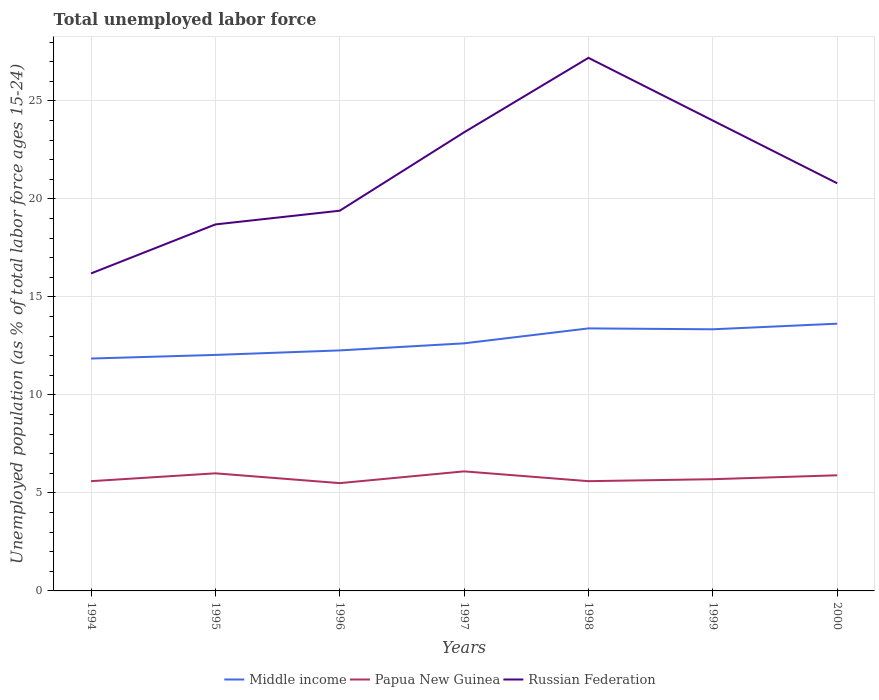Across all years, what is the maximum percentage of unemployed population in in Middle income?
Provide a succinct answer. 11.86. In which year was the percentage of unemployed population in in Russian Federation maximum?
Ensure brevity in your answer.  1994. What is the total percentage of unemployed population in in Middle income in the graph?
Keep it short and to the point. -1.31. What is the difference between the highest and the second highest percentage of unemployed population in in Papua New Guinea?
Your response must be concise. 0.6. What is the difference between the highest and the lowest percentage of unemployed population in in Middle income?
Provide a succinct answer. 3. How many years are there in the graph?
Keep it short and to the point. 7. What is the difference between two consecutive major ticks on the Y-axis?
Your answer should be very brief. 5. Are the values on the major ticks of Y-axis written in scientific E-notation?
Give a very brief answer. No. Does the graph contain grids?
Your answer should be very brief. Yes. Where does the legend appear in the graph?
Your answer should be very brief. Bottom center. How many legend labels are there?
Provide a succinct answer. 3. What is the title of the graph?
Ensure brevity in your answer.  Total unemployed labor force. What is the label or title of the Y-axis?
Your response must be concise. Unemployed population (as % of total labor force ages 15-24). What is the Unemployed population (as % of total labor force ages 15-24) of Middle income in 1994?
Make the answer very short. 11.86. What is the Unemployed population (as % of total labor force ages 15-24) of Papua New Guinea in 1994?
Provide a short and direct response. 5.6. What is the Unemployed population (as % of total labor force ages 15-24) in Russian Federation in 1994?
Provide a succinct answer. 16.2. What is the Unemployed population (as % of total labor force ages 15-24) of Middle income in 1995?
Provide a succinct answer. 12.04. What is the Unemployed population (as % of total labor force ages 15-24) in Russian Federation in 1995?
Your response must be concise. 18.7. What is the Unemployed population (as % of total labor force ages 15-24) in Middle income in 1996?
Ensure brevity in your answer.  12.27. What is the Unemployed population (as % of total labor force ages 15-24) of Papua New Guinea in 1996?
Make the answer very short. 5.5. What is the Unemployed population (as % of total labor force ages 15-24) of Russian Federation in 1996?
Make the answer very short. 19.4. What is the Unemployed population (as % of total labor force ages 15-24) in Middle income in 1997?
Give a very brief answer. 12.63. What is the Unemployed population (as % of total labor force ages 15-24) in Papua New Guinea in 1997?
Your answer should be very brief. 6.1. What is the Unemployed population (as % of total labor force ages 15-24) of Russian Federation in 1997?
Offer a very short reply. 23.4. What is the Unemployed population (as % of total labor force ages 15-24) of Middle income in 1998?
Make the answer very short. 13.4. What is the Unemployed population (as % of total labor force ages 15-24) in Papua New Guinea in 1998?
Provide a succinct answer. 5.6. What is the Unemployed population (as % of total labor force ages 15-24) of Russian Federation in 1998?
Provide a short and direct response. 27.2. What is the Unemployed population (as % of total labor force ages 15-24) of Middle income in 1999?
Give a very brief answer. 13.35. What is the Unemployed population (as % of total labor force ages 15-24) of Papua New Guinea in 1999?
Make the answer very short. 5.7. What is the Unemployed population (as % of total labor force ages 15-24) of Middle income in 2000?
Offer a terse response. 13.64. What is the Unemployed population (as % of total labor force ages 15-24) of Papua New Guinea in 2000?
Offer a very short reply. 5.9. What is the Unemployed population (as % of total labor force ages 15-24) of Russian Federation in 2000?
Your response must be concise. 20.8. Across all years, what is the maximum Unemployed population (as % of total labor force ages 15-24) in Middle income?
Ensure brevity in your answer.  13.64. Across all years, what is the maximum Unemployed population (as % of total labor force ages 15-24) in Papua New Guinea?
Keep it short and to the point. 6.1. Across all years, what is the maximum Unemployed population (as % of total labor force ages 15-24) in Russian Federation?
Offer a very short reply. 27.2. Across all years, what is the minimum Unemployed population (as % of total labor force ages 15-24) of Middle income?
Your answer should be compact. 11.86. Across all years, what is the minimum Unemployed population (as % of total labor force ages 15-24) of Papua New Guinea?
Ensure brevity in your answer.  5.5. Across all years, what is the minimum Unemployed population (as % of total labor force ages 15-24) in Russian Federation?
Ensure brevity in your answer.  16.2. What is the total Unemployed population (as % of total labor force ages 15-24) of Middle income in the graph?
Offer a very short reply. 89.18. What is the total Unemployed population (as % of total labor force ages 15-24) in Papua New Guinea in the graph?
Offer a terse response. 40.4. What is the total Unemployed population (as % of total labor force ages 15-24) in Russian Federation in the graph?
Ensure brevity in your answer.  149.7. What is the difference between the Unemployed population (as % of total labor force ages 15-24) of Middle income in 1994 and that in 1995?
Your response must be concise. -0.18. What is the difference between the Unemployed population (as % of total labor force ages 15-24) of Russian Federation in 1994 and that in 1995?
Provide a short and direct response. -2.5. What is the difference between the Unemployed population (as % of total labor force ages 15-24) of Middle income in 1994 and that in 1996?
Offer a very short reply. -0.41. What is the difference between the Unemployed population (as % of total labor force ages 15-24) in Middle income in 1994 and that in 1997?
Keep it short and to the point. -0.78. What is the difference between the Unemployed population (as % of total labor force ages 15-24) in Russian Federation in 1994 and that in 1997?
Ensure brevity in your answer.  -7.2. What is the difference between the Unemployed population (as % of total labor force ages 15-24) of Middle income in 1994 and that in 1998?
Your response must be concise. -1.54. What is the difference between the Unemployed population (as % of total labor force ages 15-24) of Russian Federation in 1994 and that in 1998?
Give a very brief answer. -11. What is the difference between the Unemployed population (as % of total labor force ages 15-24) in Middle income in 1994 and that in 1999?
Ensure brevity in your answer.  -1.49. What is the difference between the Unemployed population (as % of total labor force ages 15-24) in Papua New Guinea in 1994 and that in 1999?
Offer a terse response. -0.1. What is the difference between the Unemployed population (as % of total labor force ages 15-24) of Middle income in 1994 and that in 2000?
Give a very brief answer. -1.78. What is the difference between the Unemployed population (as % of total labor force ages 15-24) of Middle income in 1995 and that in 1996?
Give a very brief answer. -0.23. What is the difference between the Unemployed population (as % of total labor force ages 15-24) of Papua New Guinea in 1995 and that in 1996?
Keep it short and to the point. 0.5. What is the difference between the Unemployed population (as % of total labor force ages 15-24) in Middle income in 1995 and that in 1997?
Your response must be concise. -0.59. What is the difference between the Unemployed population (as % of total labor force ages 15-24) in Papua New Guinea in 1995 and that in 1997?
Your answer should be compact. -0.1. What is the difference between the Unemployed population (as % of total labor force ages 15-24) in Russian Federation in 1995 and that in 1997?
Your response must be concise. -4.7. What is the difference between the Unemployed population (as % of total labor force ages 15-24) of Middle income in 1995 and that in 1998?
Your answer should be very brief. -1.35. What is the difference between the Unemployed population (as % of total labor force ages 15-24) of Russian Federation in 1995 and that in 1998?
Ensure brevity in your answer.  -8.5. What is the difference between the Unemployed population (as % of total labor force ages 15-24) of Middle income in 1995 and that in 1999?
Give a very brief answer. -1.31. What is the difference between the Unemployed population (as % of total labor force ages 15-24) of Russian Federation in 1995 and that in 1999?
Keep it short and to the point. -5.3. What is the difference between the Unemployed population (as % of total labor force ages 15-24) of Middle income in 1995 and that in 2000?
Ensure brevity in your answer.  -1.59. What is the difference between the Unemployed population (as % of total labor force ages 15-24) of Papua New Guinea in 1995 and that in 2000?
Provide a short and direct response. 0.1. What is the difference between the Unemployed population (as % of total labor force ages 15-24) in Middle income in 1996 and that in 1997?
Your answer should be very brief. -0.36. What is the difference between the Unemployed population (as % of total labor force ages 15-24) in Middle income in 1996 and that in 1998?
Provide a short and direct response. -1.12. What is the difference between the Unemployed population (as % of total labor force ages 15-24) in Russian Federation in 1996 and that in 1998?
Offer a terse response. -7.8. What is the difference between the Unemployed population (as % of total labor force ages 15-24) of Middle income in 1996 and that in 1999?
Offer a very short reply. -1.08. What is the difference between the Unemployed population (as % of total labor force ages 15-24) in Russian Federation in 1996 and that in 1999?
Offer a terse response. -4.6. What is the difference between the Unemployed population (as % of total labor force ages 15-24) in Middle income in 1996 and that in 2000?
Provide a short and direct response. -1.36. What is the difference between the Unemployed population (as % of total labor force ages 15-24) in Middle income in 1997 and that in 1998?
Keep it short and to the point. -0.76. What is the difference between the Unemployed population (as % of total labor force ages 15-24) in Russian Federation in 1997 and that in 1998?
Ensure brevity in your answer.  -3.8. What is the difference between the Unemployed population (as % of total labor force ages 15-24) in Middle income in 1997 and that in 1999?
Offer a very short reply. -0.72. What is the difference between the Unemployed population (as % of total labor force ages 15-24) in Russian Federation in 1997 and that in 1999?
Provide a short and direct response. -0.6. What is the difference between the Unemployed population (as % of total labor force ages 15-24) of Middle income in 1997 and that in 2000?
Provide a short and direct response. -1. What is the difference between the Unemployed population (as % of total labor force ages 15-24) in Middle income in 1998 and that in 1999?
Provide a succinct answer. 0.05. What is the difference between the Unemployed population (as % of total labor force ages 15-24) in Papua New Guinea in 1998 and that in 1999?
Offer a very short reply. -0.1. What is the difference between the Unemployed population (as % of total labor force ages 15-24) of Russian Federation in 1998 and that in 1999?
Give a very brief answer. 3.2. What is the difference between the Unemployed population (as % of total labor force ages 15-24) in Middle income in 1998 and that in 2000?
Give a very brief answer. -0.24. What is the difference between the Unemployed population (as % of total labor force ages 15-24) of Papua New Guinea in 1998 and that in 2000?
Your answer should be very brief. -0.3. What is the difference between the Unemployed population (as % of total labor force ages 15-24) of Russian Federation in 1998 and that in 2000?
Keep it short and to the point. 6.4. What is the difference between the Unemployed population (as % of total labor force ages 15-24) of Middle income in 1999 and that in 2000?
Ensure brevity in your answer.  -0.29. What is the difference between the Unemployed population (as % of total labor force ages 15-24) in Middle income in 1994 and the Unemployed population (as % of total labor force ages 15-24) in Papua New Guinea in 1995?
Make the answer very short. 5.86. What is the difference between the Unemployed population (as % of total labor force ages 15-24) of Middle income in 1994 and the Unemployed population (as % of total labor force ages 15-24) of Russian Federation in 1995?
Provide a succinct answer. -6.84. What is the difference between the Unemployed population (as % of total labor force ages 15-24) of Middle income in 1994 and the Unemployed population (as % of total labor force ages 15-24) of Papua New Guinea in 1996?
Your response must be concise. 6.36. What is the difference between the Unemployed population (as % of total labor force ages 15-24) of Middle income in 1994 and the Unemployed population (as % of total labor force ages 15-24) of Russian Federation in 1996?
Provide a short and direct response. -7.54. What is the difference between the Unemployed population (as % of total labor force ages 15-24) in Papua New Guinea in 1994 and the Unemployed population (as % of total labor force ages 15-24) in Russian Federation in 1996?
Provide a short and direct response. -13.8. What is the difference between the Unemployed population (as % of total labor force ages 15-24) of Middle income in 1994 and the Unemployed population (as % of total labor force ages 15-24) of Papua New Guinea in 1997?
Provide a short and direct response. 5.76. What is the difference between the Unemployed population (as % of total labor force ages 15-24) of Middle income in 1994 and the Unemployed population (as % of total labor force ages 15-24) of Russian Federation in 1997?
Your response must be concise. -11.54. What is the difference between the Unemployed population (as % of total labor force ages 15-24) of Papua New Guinea in 1994 and the Unemployed population (as % of total labor force ages 15-24) of Russian Federation in 1997?
Offer a very short reply. -17.8. What is the difference between the Unemployed population (as % of total labor force ages 15-24) of Middle income in 1994 and the Unemployed population (as % of total labor force ages 15-24) of Papua New Guinea in 1998?
Offer a very short reply. 6.26. What is the difference between the Unemployed population (as % of total labor force ages 15-24) in Middle income in 1994 and the Unemployed population (as % of total labor force ages 15-24) in Russian Federation in 1998?
Ensure brevity in your answer.  -15.34. What is the difference between the Unemployed population (as % of total labor force ages 15-24) of Papua New Guinea in 1994 and the Unemployed population (as % of total labor force ages 15-24) of Russian Federation in 1998?
Offer a very short reply. -21.6. What is the difference between the Unemployed population (as % of total labor force ages 15-24) in Middle income in 1994 and the Unemployed population (as % of total labor force ages 15-24) in Papua New Guinea in 1999?
Your answer should be compact. 6.16. What is the difference between the Unemployed population (as % of total labor force ages 15-24) in Middle income in 1994 and the Unemployed population (as % of total labor force ages 15-24) in Russian Federation in 1999?
Give a very brief answer. -12.14. What is the difference between the Unemployed population (as % of total labor force ages 15-24) in Papua New Guinea in 1994 and the Unemployed population (as % of total labor force ages 15-24) in Russian Federation in 1999?
Provide a succinct answer. -18.4. What is the difference between the Unemployed population (as % of total labor force ages 15-24) in Middle income in 1994 and the Unemployed population (as % of total labor force ages 15-24) in Papua New Guinea in 2000?
Provide a short and direct response. 5.96. What is the difference between the Unemployed population (as % of total labor force ages 15-24) in Middle income in 1994 and the Unemployed population (as % of total labor force ages 15-24) in Russian Federation in 2000?
Make the answer very short. -8.94. What is the difference between the Unemployed population (as % of total labor force ages 15-24) in Papua New Guinea in 1994 and the Unemployed population (as % of total labor force ages 15-24) in Russian Federation in 2000?
Make the answer very short. -15.2. What is the difference between the Unemployed population (as % of total labor force ages 15-24) of Middle income in 1995 and the Unemployed population (as % of total labor force ages 15-24) of Papua New Guinea in 1996?
Provide a short and direct response. 6.54. What is the difference between the Unemployed population (as % of total labor force ages 15-24) in Middle income in 1995 and the Unemployed population (as % of total labor force ages 15-24) in Russian Federation in 1996?
Your answer should be very brief. -7.36. What is the difference between the Unemployed population (as % of total labor force ages 15-24) in Middle income in 1995 and the Unemployed population (as % of total labor force ages 15-24) in Papua New Guinea in 1997?
Ensure brevity in your answer.  5.94. What is the difference between the Unemployed population (as % of total labor force ages 15-24) in Middle income in 1995 and the Unemployed population (as % of total labor force ages 15-24) in Russian Federation in 1997?
Make the answer very short. -11.36. What is the difference between the Unemployed population (as % of total labor force ages 15-24) of Papua New Guinea in 1995 and the Unemployed population (as % of total labor force ages 15-24) of Russian Federation in 1997?
Ensure brevity in your answer.  -17.4. What is the difference between the Unemployed population (as % of total labor force ages 15-24) in Middle income in 1995 and the Unemployed population (as % of total labor force ages 15-24) in Papua New Guinea in 1998?
Ensure brevity in your answer.  6.44. What is the difference between the Unemployed population (as % of total labor force ages 15-24) in Middle income in 1995 and the Unemployed population (as % of total labor force ages 15-24) in Russian Federation in 1998?
Make the answer very short. -15.16. What is the difference between the Unemployed population (as % of total labor force ages 15-24) of Papua New Guinea in 1995 and the Unemployed population (as % of total labor force ages 15-24) of Russian Federation in 1998?
Give a very brief answer. -21.2. What is the difference between the Unemployed population (as % of total labor force ages 15-24) in Middle income in 1995 and the Unemployed population (as % of total labor force ages 15-24) in Papua New Guinea in 1999?
Provide a succinct answer. 6.34. What is the difference between the Unemployed population (as % of total labor force ages 15-24) of Middle income in 1995 and the Unemployed population (as % of total labor force ages 15-24) of Russian Federation in 1999?
Provide a short and direct response. -11.96. What is the difference between the Unemployed population (as % of total labor force ages 15-24) in Middle income in 1995 and the Unemployed population (as % of total labor force ages 15-24) in Papua New Guinea in 2000?
Make the answer very short. 6.14. What is the difference between the Unemployed population (as % of total labor force ages 15-24) of Middle income in 1995 and the Unemployed population (as % of total labor force ages 15-24) of Russian Federation in 2000?
Ensure brevity in your answer.  -8.76. What is the difference between the Unemployed population (as % of total labor force ages 15-24) of Papua New Guinea in 1995 and the Unemployed population (as % of total labor force ages 15-24) of Russian Federation in 2000?
Offer a very short reply. -14.8. What is the difference between the Unemployed population (as % of total labor force ages 15-24) in Middle income in 1996 and the Unemployed population (as % of total labor force ages 15-24) in Papua New Guinea in 1997?
Your answer should be compact. 6.17. What is the difference between the Unemployed population (as % of total labor force ages 15-24) in Middle income in 1996 and the Unemployed population (as % of total labor force ages 15-24) in Russian Federation in 1997?
Offer a terse response. -11.13. What is the difference between the Unemployed population (as % of total labor force ages 15-24) in Papua New Guinea in 1996 and the Unemployed population (as % of total labor force ages 15-24) in Russian Federation in 1997?
Your answer should be very brief. -17.9. What is the difference between the Unemployed population (as % of total labor force ages 15-24) of Middle income in 1996 and the Unemployed population (as % of total labor force ages 15-24) of Papua New Guinea in 1998?
Ensure brevity in your answer.  6.67. What is the difference between the Unemployed population (as % of total labor force ages 15-24) in Middle income in 1996 and the Unemployed population (as % of total labor force ages 15-24) in Russian Federation in 1998?
Your answer should be compact. -14.93. What is the difference between the Unemployed population (as % of total labor force ages 15-24) in Papua New Guinea in 1996 and the Unemployed population (as % of total labor force ages 15-24) in Russian Federation in 1998?
Make the answer very short. -21.7. What is the difference between the Unemployed population (as % of total labor force ages 15-24) of Middle income in 1996 and the Unemployed population (as % of total labor force ages 15-24) of Papua New Guinea in 1999?
Your answer should be very brief. 6.57. What is the difference between the Unemployed population (as % of total labor force ages 15-24) of Middle income in 1996 and the Unemployed population (as % of total labor force ages 15-24) of Russian Federation in 1999?
Make the answer very short. -11.73. What is the difference between the Unemployed population (as % of total labor force ages 15-24) in Papua New Guinea in 1996 and the Unemployed population (as % of total labor force ages 15-24) in Russian Federation in 1999?
Offer a terse response. -18.5. What is the difference between the Unemployed population (as % of total labor force ages 15-24) of Middle income in 1996 and the Unemployed population (as % of total labor force ages 15-24) of Papua New Guinea in 2000?
Give a very brief answer. 6.37. What is the difference between the Unemployed population (as % of total labor force ages 15-24) in Middle income in 1996 and the Unemployed population (as % of total labor force ages 15-24) in Russian Federation in 2000?
Provide a succinct answer. -8.53. What is the difference between the Unemployed population (as % of total labor force ages 15-24) of Papua New Guinea in 1996 and the Unemployed population (as % of total labor force ages 15-24) of Russian Federation in 2000?
Keep it short and to the point. -15.3. What is the difference between the Unemployed population (as % of total labor force ages 15-24) of Middle income in 1997 and the Unemployed population (as % of total labor force ages 15-24) of Papua New Guinea in 1998?
Give a very brief answer. 7.03. What is the difference between the Unemployed population (as % of total labor force ages 15-24) of Middle income in 1997 and the Unemployed population (as % of total labor force ages 15-24) of Russian Federation in 1998?
Offer a very short reply. -14.57. What is the difference between the Unemployed population (as % of total labor force ages 15-24) in Papua New Guinea in 1997 and the Unemployed population (as % of total labor force ages 15-24) in Russian Federation in 1998?
Your response must be concise. -21.1. What is the difference between the Unemployed population (as % of total labor force ages 15-24) of Middle income in 1997 and the Unemployed population (as % of total labor force ages 15-24) of Papua New Guinea in 1999?
Offer a very short reply. 6.93. What is the difference between the Unemployed population (as % of total labor force ages 15-24) of Middle income in 1997 and the Unemployed population (as % of total labor force ages 15-24) of Russian Federation in 1999?
Your response must be concise. -11.37. What is the difference between the Unemployed population (as % of total labor force ages 15-24) in Papua New Guinea in 1997 and the Unemployed population (as % of total labor force ages 15-24) in Russian Federation in 1999?
Offer a very short reply. -17.9. What is the difference between the Unemployed population (as % of total labor force ages 15-24) in Middle income in 1997 and the Unemployed population (as % of total labor force ages 15-24) in Papua New Guinea in 2000?
Make the answer very short. 6.73. What is the difference between the Unemployed population (as % of total labor force ages 15-24) in Middle income in 1997 and the Unemployed population (as % of total labor force ages 15-24) in Russian Federation in 2000?
Provide a succinct answer. -8.17. What is the difference between the Unemployed population (as % of total labor force ages 15-24) of Papua New Guinea in 1997 and the Unemployed population (as % of total labor force ages 15-24) of Russian Federation in 2000?
Your answer should be compact. -14.7. What is the difference between the Unemployed population (as % of total labor force ages 15-24) of Middle income in 1998 and the Unemployed population (as % of total labor force ages 15-24) of Papua New Guinea in 1999?
Your response must be concise. 7.7. What is the difference between the Unemployed population (as % of total labor force ages 15-24) in Middle income in 1998 and the Unemployed population (as % of total labor force ages 15-24) in Russian Federation in 1999?
Ensure brevity in your answer.  -10.61. What is the difference between the Unemployed population (as % of total labor force ages 15-24) of Papua New Guinea in 1998 and the Unemployed population (as % of total labor force ages 15-24) of Russian Federation in 1999?
Your answer should be compact. -18.4. What is the difference between the Unemployed population (as % of total labor force ages 15-24) in Middle income in 1998 and the Unemployed population (as % of total labor force ages 15-24) in Papua New Guinea in 2000?
Provide a short and direct response. 7.5. What is the difference between the Unemployed population (as % of total labor force ages 15-24) of Middle income in 1998 and the Unemployed population (as % of total labor force ages 15-24) of Russian Federation in 2000?
Offer a terse response. -7.41. What is the difference between the Unemployed population (as % of total labor force ages 15-24) of Papua New Guinea in 1998 and the Unemployed population (as % of total labor force ages 15-24) of Russian Federation in 2000?
Offer a terse response. -15.2. What is the difference between the Unemployed population (as % of total labor force ages 15-24) of Middle income in 1999 and the Unemployed population (as % of total labor force ages 15-24) of Papua New Guinea in 2000?
Offer a very short reply. 7.45. What is the difference between the Unemployed population (as % of total labor force ages 15-24) of Middle income in 1999 and the Unemployed population (as % of total labor force ages 15-24) of Russian Federation in 2000?
Your answer should be compact. -7.45. What is the difference between the Unemployed population (as % of total labor force ages 15-24) in Papua New Guinea in 1999 and the Unemployed population (as % of total labor force ages 15-24) in Russian Federation in 2000?
Your answer should be compact. -15.1. What is the average Unemployed population (as % of total labor force ages 15-24) in Middle income per year?
Ensure brevity in your answer.  12.74. What is the average Unemployed population (as % of total labor force ages 15-24) in Papua New Guinea per year?
Keep it short and to the point. 5.77. What is the average Unemployed population (as % of total labor force ages 15-24) in Russian Federation per year?
Ensure brevity in your answer.  21.39. In the year 1994, what is the difference between the Unemployed population (as % of total labor force ages 15-24) in Middle income and Unemployed population (as % of total labor force ages 15-24) in Papua New Guinea?
Your answer should be very brief. 6.26. In the year 1994, what is the difference between the Unemployed population (as % of total labor force ages 15-24) of Middle income and Unemployed population (as % of total labor force ages 15-24) of Russian Federation?
Provide a succinct answer. -4.34. In the year 1994, what is the difference between the Unemployed population (as % of total labor force ages 15-24) of Papua New Guinea and Unemployed population (as % of total labor force ages 15-24) of Russian Federation?
Your answer should be very brief. -10.6. In the year 1995, what is the difference between the Unemployed population (as % of total labor force ages 15-24) in Middle income and Unemployed population (as % of total labor force ages 15-24) in Papua New Guinea?
Your response must be concise. 6.04. In the year 1995, what is the difference between the Unemployed population (as % of total labor force ages 15-24) in Middle income and Unemployed population (as % of total labor force ages 15-24) in Russian Federation?
Offer a terse response. -6.66. In the year 1996, what is the difference between the Unemployed population (as % of total labor force ages 15-24) of Middle income and Unemployed population (as % of total labor force ages 15-24) of Papua New Guinea?
Offer a terse response. 6.77. In the year 1996, what is the difference between the Unemployed population (as % of total labor force ages 15-24) of Middle income and Unemployed population (as % of total labor force ages 15-24) of Russian Federation?
Your answer should be compact. -7.13. In the year 1996, what is the difference between the Unemployed population (as % of total labor force ages 15-24) of Papua New Guinea and Unemployed population (as % of total labor force ages 15-24) of Russian Federation?
Provide a succinct answer. -13.9. In the year 1997, what is the difference between the Unemployed population (as % of total labor force ages 15-24) of Middle income and Unemployed population (as % of total labor force ages 15-24) of Papua New Guinea?
Give a very brief answer. 6.53. In the year 1997, what is the difference between the Unemployed population (as % of total labor force ages 15-24) in Middle income and Unemployed population (as % of total labor force ages 15-24) in Russian Federation?
Provide a succinct answer. -10.77. In the year 1997, what is the difference between the Unemployed population (as % of total labor force ages 15-24) of Papua New Guinea and Unemployed population (as % of total labor force ages 15-24) of Russian Federation?
Provide a short and direct response. -17.3. In the year 1998, what is the difference between the Unemployed population (as % of total labor force ages 15-24) in Middle income and Unemployed population (as % of total labor force ages 15-24) in Papua New Guinea?
Provide a succinct answer. 7.79. In the year 1998, what is the difference between the Unemployed population (as % of total labor force ages 15-24) of Middle income and Unemployed population (as % of total labor force ages 15-24) of Russian Federation?
Give a very brief answer. -13.8. In the year 1998, what is the difference between the Unemployed population (as % of total labor force ages 15-24) in Papua New Guinea and Unemployed population (as % of total labor force ages 15-24) in Russian Federation?
Make the answer very short. -21.6. In the year 1999, what is the difference between the Unemployed population (as % of total labor force ages 15-24) of Middle income and Unemployed population (as % of total labor force ages 15-24) of Papua New Guinea?
Make the answer very short. 7.65. In the year 1999, what is the difference between the Unemployed population (as % of total labor force ages 15-24) in Middle income and Unemployed population (as % of total labor force ages 15-24) in Russian Federation?
Offer a terse response. -10.65. In the year 1999, what is the difference between the Unemployed population (as % of total labor force ages 15-24) in Papua New Guinea and Unemployed population (as % of total labor force ages 15-24) in Russian Federation?
Your answer should be very brief. -18.3. In the year 2000, what is the difference between the Unemployed population (as % of total labor force ages 15-24) in Middle income and Unemployed population (as % of total labor force ages 15-24) in Papua New Guinea?
Offer a terse response. 7.74. In the year 2000, what is the difference between the Unemployed population (as % of total labor force ages 15-24) of Middle income and Unemployed population (as % of total labor force ages 15-24) of Russian Federation?
Offer a very short reply. -7.16. In the year 2000, what is the difference between the Unemployed population (as % of total labor force ages 15-24) of Papua New Guinea and Unemployed population (as % of total labor force ages 15-24) of Russian Federation?
Provide a succinct answer. -14.9. What is the ratio of the Unemployed population (as % of total labor force ages 15-24) of Middle income in 1994 to that in 1995?
Make the answer very short. 0.98. What is the ratio of the Unemployed population (as % of total labor force ages 15-24) in Papua New Guinea in 1994 to that in 1995?
Offer a very short reply. 0.93. What is the ratio of the Unemployed population (as % of total labor force ages 15-24) of Russian Federation in 1994 to that in 1995?
Offer a terse response. 0.87. What is the ratio of the Unemployed population (as % of total labor force ages 15-24) in Middle income in 1994 to that in 1996?
Offer a very short reply. 0.97. What is the ratio of the Unemployed population (as % of total labor force ages 15-24) in Papua New Guinea in 1994 to that in 1996?
Offer a very short reply. 1.02. What is the ratio of the Unemployed population (as % of total labor force ages 15-24) of Russian Federation in 1994 to that in 1996?
Your response must be concise. 0.84. What is the ratio of the Unemployed population (as % of total labor force ages 15-24) of Middle income in 1994 to that in 1997?
Your answer should be compact. 0.94. What is the ratio of the Unemployed population (as % of total labor force ages 15-24) in Papua New Guinea in 1994 to that in 1997?
Make the answer very short. 0.92. What is the ratio of the Unemployed population (as % of total labor force ages 15-24) of Russian Federation in 1994 to that in 1997?
Provide a short and direct response. 0.69. What is the ratio of the Unemployed population (as % of total labor force ages 15-24) of Middle income in 1994 to that in 1998?
Make the answer very short. 0.89. What is the ratio of the Unemployed population (as % of total labor force ages 15-24) of Papua New Guinea in 1994 to that in 1998?
Keep it short and to the point. 1. What is the ratio of the Unemployed population (as % of total labor force ages 15-24) of Russian Federation in 1994 to that in 1998?
Your answer should be very brief. 0.6. What is the ratio of the Unemployed population (as % of total labor force ages 15-24) of Middle income in 1994 to that in 1999?
Give a very brief answer. 0.89. What is the ratio of the Unemployed population (as % of total labor force ages 15-24) of Papua New Guinea in 1994 to that in 1999?
Provide a short and direct response. 0.98. What is the ratio of the Unemployed population (as % of total labor force ages 15-24) in Russian Federation in 1994 to that in 1999?
Provide a short and direct response. 0.68. What is the ratio of the Unemployed population (as % of total labor force ages 15-24) in Middle income in 1994 to that in 2000?
Your response must be concise. 0.87. What is the ratio of the Unemployed population (as % of total labor force ages 15-24) of Papua New Guinea in 1994 to that in 2000?
Make the answer very short. 0.95. What is the ratio of the Unemployed population (as % of total labor force ages 15-24) of Russian Federation in 1994 to that in 2000?
Keep it short and to the point. 0.78. What is the ratio of the Unemployed population (as % of total labor force ages 15-24) of Middle income in 1995 to that in 1996?
Offer a terse response. 0.98. What is the ratio of the Unemployed population (as % of total labor force ages 15-24) of Russian Federation in 1995 to that in 1996?
Your response must be concise. 0.96. What is the ratio of the Unemployed population (as % of total labor force ages 15-24) of Middle income in 1995 to that in 1997?
Your answer should be very brief. 0.95. What is the ratio of the Unemployed population (as % of total labor force ages 15-24) in Papua New Guinea in 1995 to that in 1997?
Give a very brief answer. 0.98. What is the ratio of the Unemployed population (as % of total labor force ages 15-24) in Russian Federation in 1995 to that in 1997?
Offer a very short reply. 0.8. What is the ratio of the Unemployed population (as % of total labor force ages 15-24) in Middle income in 1995 to that in 1998?
Your response must be concise. 0.9. What is the ratio of the Unemployed population (as % of total labor force ages 15-24) of Papua New Guinea in 1995 to that in 1998?
Offer a very short reply. 1.07. What is the ratio of the Unemployed population (as % of total labor force ages 15-24) in Russian Federation in 1995 to that in 1998?
Keep it short and to the point. 0.69. What is the ratio of the Unemployed population (as % of total labor force ages 15-24) in Middle income in 1995 to that in 1999?
Offer a very short reply. 0.9. What is the ratio of the Unemployed population (as % of total labor force ages 15-24) in Papua New Guinea in 1995 to that in 1999?
Make the answer very short. 1.05. What is the ratio of the Unemployed population (as % of total labor force ages 15-24) of Russian Federation in 1995 to that in 1999?
Make the answer very short. 0.78. What is the ratio of the Unemployed population (as % of total labor force ages 15-24) of Middle income in 1995 to that in 2000?
Provide a short and direct response. 0.88. What is the ratio of the Unemployed population (as % of total labor force ages 15-24) of Papua New Guinea in 1995 to that in 2000?
Keep it short and to the point. 1.02. What is the ratio of the Unemployed population (as % of total labor force ages 15-24) of Russian Federation in 1995 to that in 2000?
Make the answer very short. 0.9. What is the ratio of the Unemployed population (as % of total labor force ages 15-24) of Middle income in 1996 to that in 1997?
Keep it short and to the point. 0.97. What is the ratio of the Unemployed population (as % of total labor force ages 15-24) of Papua New Guinea in 1996 to that in 1997?
Keep it short and to the point. 0.9. What is the ratio of the Unemployed population (as % of total labor force ages 15-24) of Russian Federation in 1996 to that in 1997?
Provide a succinct answer. 0.83. What is the ratio of the Unemployed population (as % of total labor force ages 15-24) of Middle income in 1996 to that in 1998?
Ensure brevity in your answer.  0.92. What is the ratio of the Unemployed population (as % of total labor force ages 15-24) of Papua New Guinea in 1996 to that in 1998?
Provide a succinct answer. 0.98. What is the ratio of the Unemployed population (as % of total labor force ages 15-24) in Russian Federation in 1996 to that in 1998?
Offer a very short reply. 0.71. What is the ratio of the Unemployed population (as % of total labor force ages 15-24) of Middle income in 1996 to that in 1999?
Your response must be concise. 0.92. What is the ratio of the Unemployed population (as % of total labor force ages 15-24) of Papua New Guinea in 1996 to that in 1999?
Offer a very short reply. 0.96. What is the ratio of the Unemployed population (as % of total labor force ages 15-24) in Russian Federation in 1996 to that in 1999?
Make the answer very short. 0.81. What is the ratio of the Unemployed population (as % of total labor force ages 15-24) of Middle income in 1996 to that in 2000?
Provide a short and direct response. 0.9. What is the ratio of the Unemployed population (as % of total labor force ages 15-24) of Papua New Guinea in 1996 to that in 2000?
Offer a very short reply. 0.93. What is the ratio of the Unemployed population (as % of total labor force ages 15-24) of Russian Federation in 1996 to that in 2000?
Offer a very short reply. 0.93. What is the ratio of the Unemployed population (as % of total labor force ages 15-24) of Middle income in 1997 to that in 1998?
Your response must be concise. 0.94. What is the ratio of the Unemployed population (as % of total labor force ages 15-24) of Papua New Guinea in 1997 to that in 1998?
Your answer should be compact. 1.09. What is the ratio of the Unemployed population (as % of total labor force ages 15-24) of Russian Federation in 1997 to that in 1998?
Keep it short and to the point. 0.86. What is the ratio of the Unemployed population (as % of total labor force ages 15-24) in Middle income in 1997 to that in 1999?
Ensure brevity in your answer.  0.95. What is the ratio of the Unemployed population (as % of total labor force ages 15-24) in Papua New Guinea in 1997 to that in 1999?
Your answer should be compact. 1.07. What is the ratio of the Unemployed population (as % of total labor force ages 15-24) in Russian Federation in 1997 to that in 1999?
Make the answer very short. 0.97. What is the ratio of the Unemployed population (as % of total labor force ages 15-24) of Middle income in 1997 to that in 2000?
Make the answer very short. 0.93. What is the ratio of the Unemployed population (as % of total labor force ages 15-24) in Papua New Guinea in 1997 to that in 2000?
Your answer should be compact. 1.03. What is the ratio of the Unemployed population (as % of total labor force ages 15-24) of Papua New Guinea in 1998 to that in 1999?
Your answer should be compact. 0.98. What is the ratio of the Unemployed population (as % of total labor force ages 15-24) in Russian Federation in 1998 to that in 1999?
Make the answer very short. 1.13. What is the ratio of the Unemployed population (as % of total labor force ages 15-24) in Middle income in 1998 to that in 2000?
Your answer should be very brief. 0.98. What is the ratio of the Unemployed population (as % of total labor force ages 15-24) of Papua New Guinea in 1998 to that in 2000?
Provide a short and direct response. 0.95. What is the ratio of the Unemployed population (as % of total labor force ages 15-24) in Russian Federation in 1998 to that in 2000?
Keep it short and to the point. 1.31. What is the ratio of the Unemployed population (as % of total labor force ages 15-24) of Middle income in 1999 to that in 2000?
Your answer should be very brief. 0.98. What is the ratio of the Unemployed population (as % of total labor force ages 15-24) in Papua New Guinea in 1999 to that in 2000?
Your response must be concise. 0.97. What is the ratio of the Unemployed population (as % of total labor force ages 15-24) of Russian Federation in 1999 to that in 2000?
Provide a succinct answer. 1.15. What is the difference between the highest and the second highest Unemployed population (as % of total labor force ages 15-24) of Middle income?
Ensure brevity in your answer.  0.24. What is the difference between the highest and the lowest Unemployed population (as % of total labor force ages 15-24) in Middle income?
Give a very brief answer. 1.78. What is the difference between the highest and the lowest Unemployed population (as % of total labor force ages 15-24) of Papua New Guinea?
Your answer should be very brief. 0.6. What is the difference between the highest and the lowest Unemployed population (as % of total labor force ages 15-24) in Russian Federation?
Give a very brief answer. 11. 